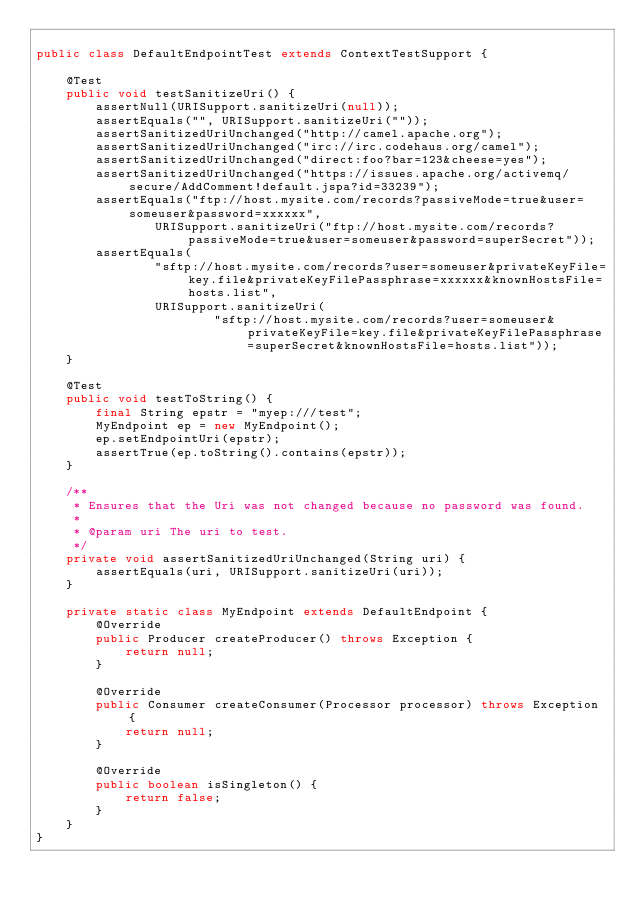Convert code to text. <code><loc_0><loc_0><loc_500><loc_500><_Java_>
public class DefaultEndpointTest extends ContextTestSupport {

    @Test
    public void testSanitizeUri() {
        assertNull(URISupport.sanitizeUri(null));
        assertEquals("", URISupport.sanitizeUri(""));
        assertSanitizedUriUnchanged("http://camel.apache.org");
        assertSanitizedUriUnchanged("irc://irc.codehaus.org/camel");
        assertSanitizedUriUnchanged("direct:foo?bar=123&cheese=yes");
        assertSanitizedUriUnchanged("https://issues.apache.org/activemq/secure/AddComment!default.jspa?id=33239");
        assertEquals("ftp://host.mysite.com/records?passiveMode=true&user=someuser&password=xxxxxx",
                URISupport.sanitizeUri("ftp://host.mysite.com/records?passiveMode=true&user=someuser&password=superSecret"));
        assertEquals(
                "sftp://host.mysite.com/records?user=someuser&privateKeyFile=key.file&privateKeyFilePassphrase=xxxxxx&knownHostsFile=hosts.list",
                URISupport.sanitizeUri(
                        "sftp://host.mysite.com/records?user=someuser&privateKeyFile=key.file&privateKeyFilePassphrase=superSecret&knownHostsFile=hosts.list"));
    }

    @Test
    public void testToString() {
        final String epstr = "myep:///test";
        MyEndpoint ep = new MyEndpoint();
        ep.setEndpointUri(epstr);
        assertTrue(ep.toString().contains(epstr));
    }

    /**
     * Ensures that the Uri was not changed because no password was found.
     *
     * @param uri The uri to test.
     */
    private void assertSanitizedUriUnchanged(String uri) {
        assertEquals(uri, URISupport.sanitizeUri(uri));
    }

    private static class MyEndpoint extends DefaultEndpoint {
        @Override
        public Producer createProducer() throws Exception {
            return null;
        }

        @Override
        public Consumer createConsumer(Processor processor) throws Exception {
            return null;
        }

        @Override
        public boolean isSingleton() {
            return false;
        }
    }
}
</code> 